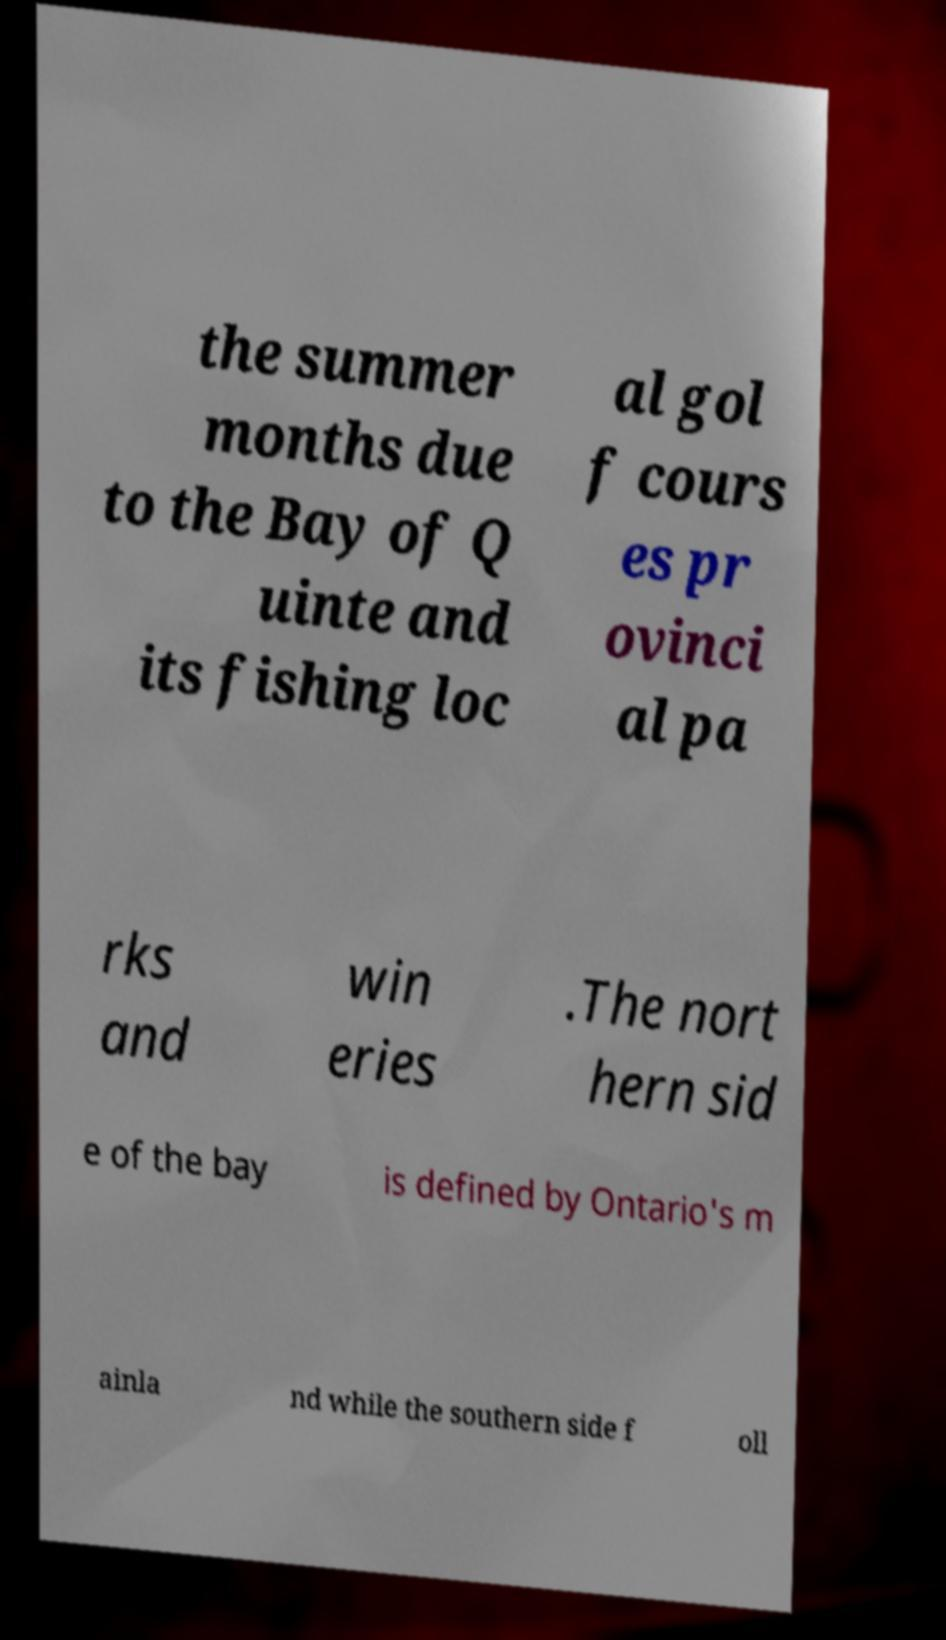Please read and relay the text visible in this image. What does it say? the summer months due to the Bay of Q uinte and its fishing loc al gol f cours es pr ovinci al pa rks and win eries .The nort hern sid e of the bay is defined by Ontario's m ainla nd while the southern side f oll 